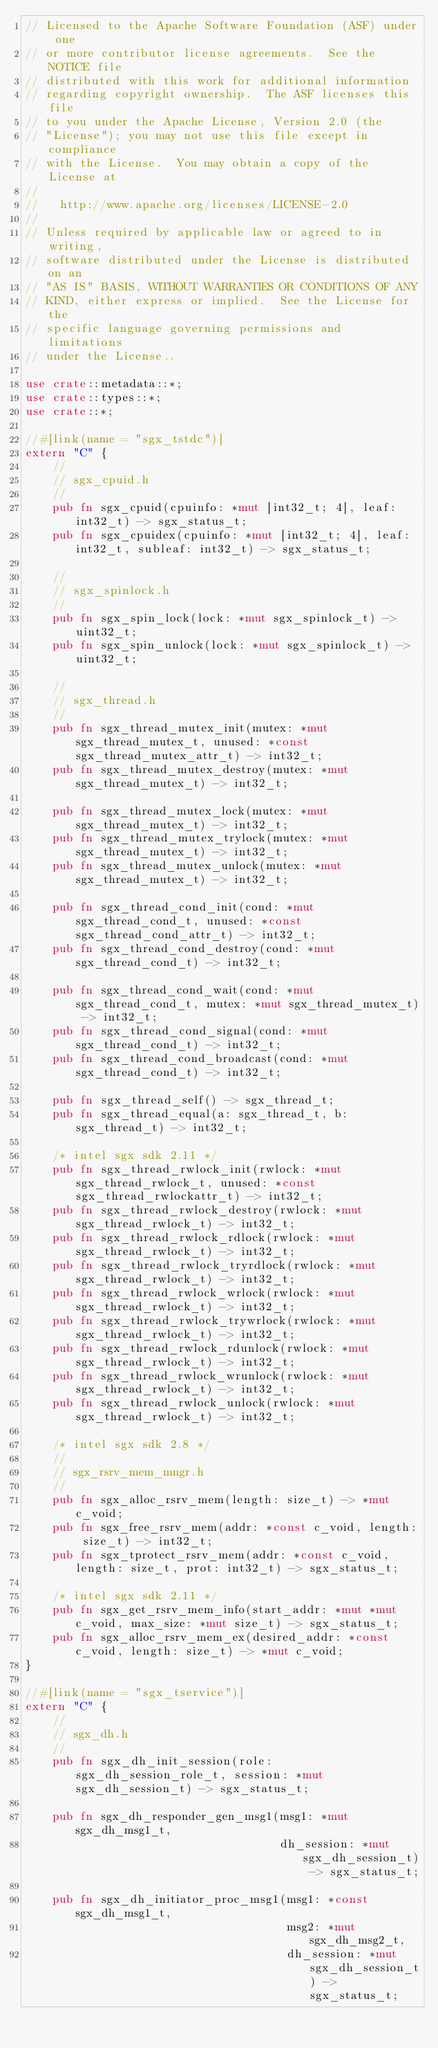Convert code to text. <code><loc_0><loc_0><loc_500><loc_500><_Rust_>// Licensed to the Apache Software Foundation (ASF) under one
// or more contributor license agreements.  See the NOTICE file
// distributed with this work for additional information
// regarding copyright ownership.  The ASF licenses this file
// to you under the Apache License, Version 2.0 (the
// "License"); you may not use this file except in compliance
// with the License.  You may obtain a copy of the License at
//
//   http://www.apache.org/licenses/LICENSE-2.0
//
// Unless required by applicable law or agreed to in writing,
// software distributed under the License is distributed on an
// "AS IS" BASIS, WITHOUT WARRANTIES OR CONDITIONS OF ANY
// KIND, either express or implied.  See the License for the
// specific language governing permissions and limitations
// under the License..

use crate::metadata::*;
use crate::types::*;
use crate::*;

//#[link(name = "sgx_tstdc")]
extern "C" {
    //
    // sgx_cpuid.h
    //
    pub fn sgx_cpuid(cpuinfo: *mut [int32_t; 4], leaf: int32_t) -> sgx_status_t;
    pub fn sgx_cpuidex(cpuinfo: *mut [int32_t; 4], leaf: int32_t, subleaf: int32_t) -> sgx_status_t;

    //
    // sgx_spinlock.h
    //
    pub fn sgx_spin_lock(lock: *mut sgx_spinlock_t) -> uint32_t;
    pub fn sgx_spin_unlock(lock: *mut sgx_spinlock_t) -> uint32_t;

    //
    // sgx_thread.h
    //
    pub fn sgx_thread_mutex_init(mutex: *mut sgx_thread_mutex_t, unused: *const sgx_thread_mutex_attr_t) -> int32_t;
    pub fn sgx_thread_mutex_destroy(mutex: *mut sgx_thread_mutex_t) -> int32_t;

    pub fn sgx_thread_mutex_lock(mutex: *mut sgx_thread_mutex_t) -> int32_t;
    pub fn sgx_thread_mutex_trylock(mutex: *mut sgx_thread_mutex_t) -> int32_t;
    pub fn sgx_thread_mutex_unlock(mutex: *mut sgx_thread_mutex_t) -> int32_t;

    pub fn sgx_thread_cond_init(cond: *mut sgx_thread_cond_t, unused: *const sgx_thread_cond_attr_t) -> int32_t;
    pub fn sgx_thread_cond_destroy(cond: *mut sgx_thread_cond_t) -> int32_t;

    pub fn sgx_thread_cond_wait(cond: *mut sgx_thread_cond_t, mutex: *mut sgx_thread_mutex_t) -> int32_t;
    pub fn sgx_thread_cond_signal(cond: *mut sgx_thread_cond_t) -> int32_t;
    pub fn sgx_thread_cond_broadcast(cond: *mut sgx_thread_cond_t) -> int32_t;

    pub fn sgx_thread_self() -> sgx_thread_t;
    pub fn sgx_thread_equal(a: sgx_thread_t, b: sgx_thread_t) -> int32_t;

    /* intel sgx sdk 2.11 */
    pub fn sgx_thread_rwlock_init(rwlock: *mut sgx_thread_rwlock_t, unused: *const sgx_thread_rwlockattr_t) -> int32_t;
    pub fn sgx_thread_rwlock_destroy(rwlock: *mut sgx_thread_rwlock_t) -> int32_t;
    pub fn sgx_thread_rwlock_rdlock(rwlock: *mut sgx_thread_rwlock_t) -> int32_t;
    pub fn sgx_thread_rwlock_tryrdlock(rwlock: *mut sgx_thread_rwlock_t) -> int32_t;
    pub fn sgx_thread_rwlock_wrlock(rwlock: *mut sgx_thread_rwlock_t) -> int32_t;
    pub fn sgx_thread_rwlock_trywrlock(rwlock: *mut sgx_thread_rwlock_t) -> int32_t;
    pub fn sgx_thread_rwlock_rdunlock(rwlock: *mut sgx_thread_rwlock_t) -> int32_t;
    pub fn sgx_thread_rwlock_wrunlock(rwlock: *mut sgx_thread_rwlock_t) -> int32_t;
    pub fn sgx_thread_rwlock_unlock(rwlock: *mut sgx_thread_rwlock_t) -> int32_t;

    /* intel sgx sdk 2.8 */
    //
    // sgx_rsrv_mem_mngr.h
    //
    pub fn sgx_alloc_rsrv_mem(length: size_t) -> *mut c_void;
    pub fn sgx_free_rsrv_mem(addr: *const c_void, length: size_t) -> int32_t;
    pub fn sgx_tprotect_rsrv_mem(addr: *const c_void, length: size_t, prot: int32_t) -> sgx_status_t;

    /* intel sgx sdk 2.11 */
    pub fn sgx_get_rsrv_mem_info(start_addr: *mut *mut c_void, max_size: *mut size_t) -> sgx_status_t;
    pub fn sgx_alloc_rsrv_mem_ex(desired_addr: *const c_void, length: size_t) -> *mut c_void;
}

//#[link(name = "sgx_tservice")]
extern "C" {
    //
    // sgx_dh.h
    //
    pub fn sgx_dh_init_session(role: sgx_dh_session_role_t, session: *mut sgx_dh_session_t) -> sgx_status_t;

    pub fn sgx_dh_responder_gen_msg1(msg1: *mut sgx_dh_msg1_t,
                                     dh_session: *mut sgx_dh_session_t) -> sgx_status_t;

    pub fn sgx_dh_initiator_proc_msg1(msg1: *const sgx_dh_msg1_t,
                                      msg2: *mut sgx_dh_msg2_t,
                                      dh_session: *mut sgx_dh_session_t) -> sgx_status_t;
</code> 